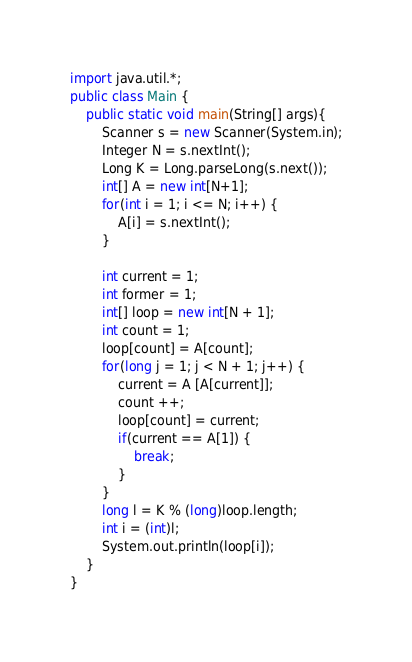<code> <loc_0><loc_0><loc_500><loc_500><_Java_>import java.util.*;
public class Main {
    public static void main(String[] args){
		Scanner s = new Scanner(System.in);
        Integer N = s.nextInt();
        Long K = Long.parseLong(s.next());
        int[] A = new int[N+1];
        for(int i = 1; i <= N; i++) {
        	A[i] = s.nextInt();
        }
        
        int current = 1;
        int former = 1;
        int[] loop = new int[N + 1];
        int count = 1;
        loop[count] = A[count]; 
        for(long j = 1; j < N + 1; j++) {
        	current = A [A[current]];
        	count ++;
        	loop[count] = current;
        	if(current == A[1]) {
        		break;
        	}
        }
        long l = K % (long)loop.length;
        int i = (int)l;
        System.out.println(loop[i]);
    }
}</code> 